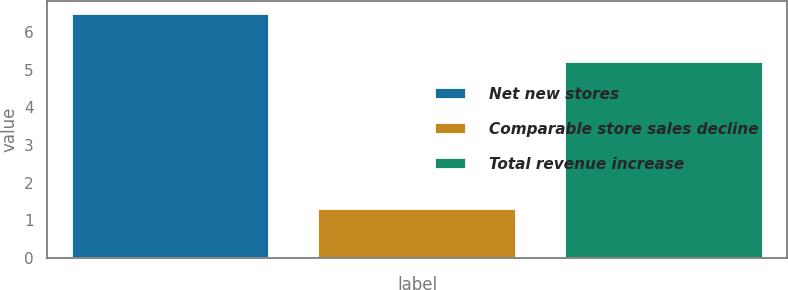Convert chart. <chart><loc_0><loc_0><loc_500><loc_500><bar_chart><fcel>Net new stores<fcel>Comparable store sales decline<fcel>Total revenue increase<nl><fcel>6.5<fcel>1.3<fcel>5.2<nl></chart> 